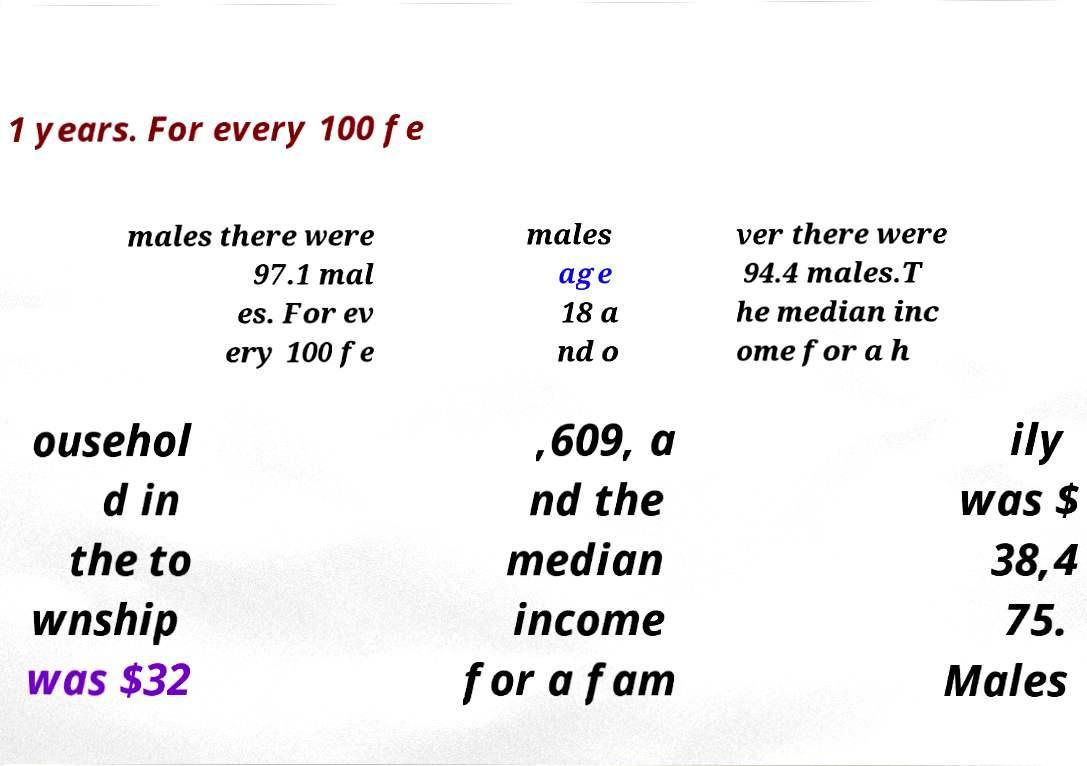What messages or text are displayed in this image? I need them in a readable, typed format. 1 years. For every 100 fe males there were 97.1 mal es. For ev ery 100 fe males age 18 a nd o ver there were 94.4 males.T he median inc ome for a h ousehol d in the to wnship was $32 ,609, a nd the median income for a fam ily was $ 38,4 75. Males 